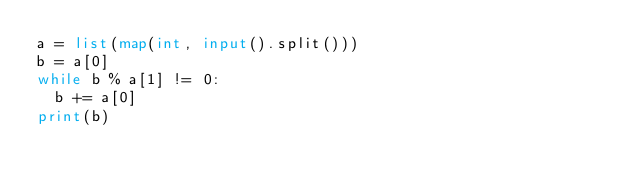<code> <loc_0><loc_0><loc_500><loc_500><_Python_>a = list(map(int, input().split()))
b = a[0]
while b % a[1] != 0:
  b += a[0]
print(b)
</code> 